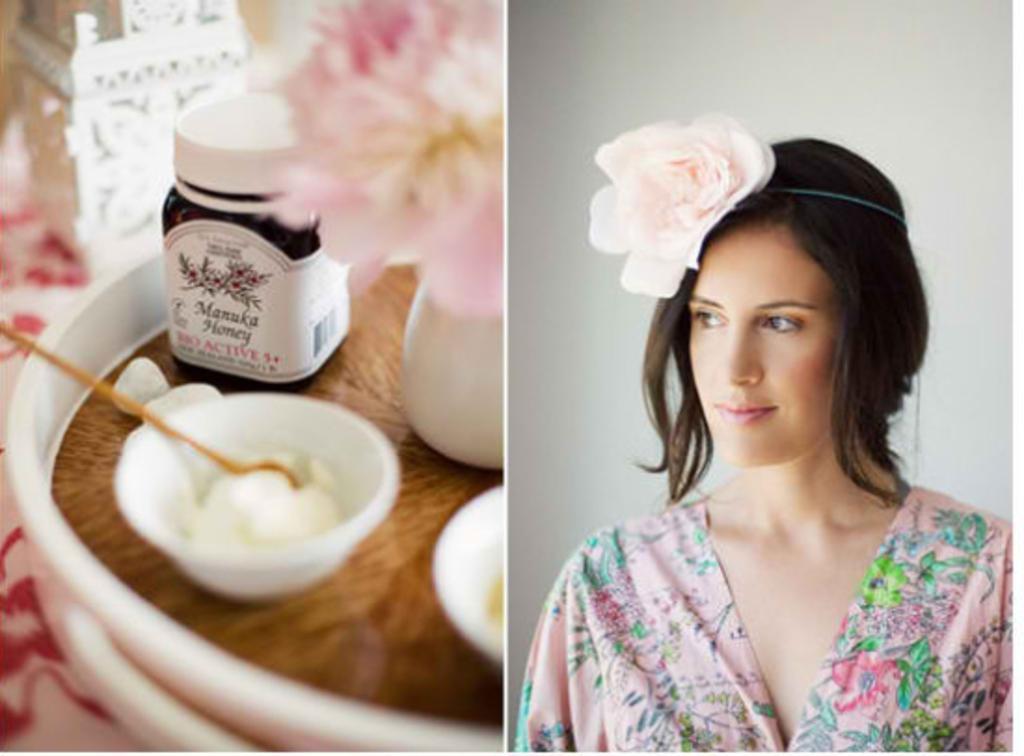Could you give a brief overview of what you see in this image? In this picture we can see a woman wearing a rose headband on her head on the right side. We can see a white background. There is a honey bottle, flower vase, cups, white objects and a silver object on the left side. 